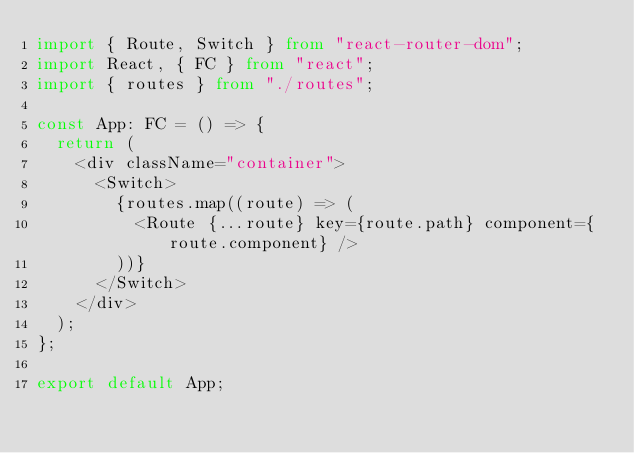Convert code to text. <code><loc_0><loc_0><loc_500><loc_500><_TypeScript_>import { Route, Switch } from "react-router-dom";
import React, { FC } from "react";
import { routes } from "./routes";

const App: FC = () => {
  return (
    <div className="container">
      <Switch>
        {routes.map((route) => (
          <Route {...route} key={route.path} component={route.component} />
        ))}
      </Switch>
    </div>
  );
};

export default App;
</code> 